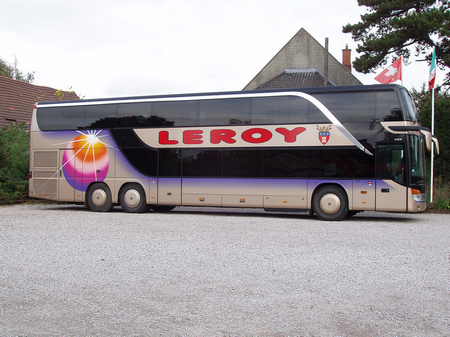Please identify all text content in this image. LEROY 